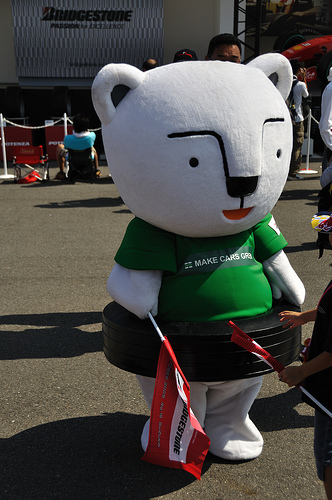<image>
Is there a bear in the tire? Yes. The bear is contained within or inside the tire, showing a containment relationship. Is the tire behind the flag? Yes. From this viewpoint, the tire is positioned behind the flag, with the flag partially or fully occluding the tire. 